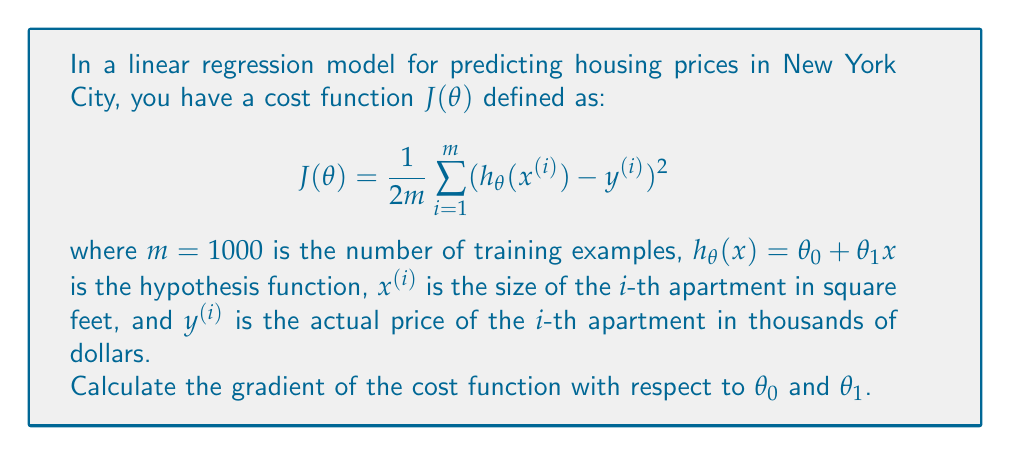Solve this math problem. To calculate the gradient of the cost function, we need to find the partial derivatives of $J(\theta)$ with respect to $\theta_0$ and $\theta_1$. Let's break this down step by step:

1) First, let's expand the hypothesis function in the cost function:
   $$J(\theta) = \frac{1}{2m} \sum_{i=1}^m ((\theta_0 + \theta_1x^{(i)}) - y^{(i)})^2$$

2) Now, let's calculate $\frac{\partial J}{\partial \theta_0}$:
   $$\begin{align}
   \frac{\partial J}{\partial \theta_0} &= \frac{\partial}{\partial \theta_0} \left[\frac{1}{2m} \sum_{i=1}^m ((\theta_0 + \theta_1x^{(i)}) - y^{(i)})^2\right] \\
   &= \frac{1}{2m} \sum_{i=1}^m 2((\theta_0 + \theta_1x^{(i)}) - y^{(i)}) \cdot \frac{\partial}{\partial \theta_0}(\theta_0 + \theta_1x^{(i)} - y^{(i)}) \\
   &= \frac{1}{m} \sum_{i=1}^m ((\theta_0 + \theta_1x^{(i)}) - y^{(i)}) \cdot 1 \\
   &= \frac{1}{m} \sum_{i=1}^m (h_\theta(x^{(i)}) - y^{(i)})
   \end{align}$$

3) Now, let's calculate $\frac{\partial J}{\partial \theta_1}$:
   $$\begin{align}
   \frac{\partial J}{\partial \theta_1} &= \frac{\partial}{\partial \theta_1} \left[\frac{1}{2m} \sum_{i=1}^m ((\theta_0 + \theta_1x^{(i)}) - y^{(i)})^2\right] \\
   &= \frac{1}{2m} \sum_{i=1}^m 2((\theta_0 + \theta_1x^{(i)}) - y^{(i)}) \cdot \frac{\partial}{\partial \theta_1}(\theta_0 + \theta_1x^{(i)} - y^{(i)}) \\
   &= \frac{1}{m} \sum_{i=1}^m ((\theta_0 + \theta_1x^{(i)}) - y^{(i)}) \cdot x^{(i)} \\
   &= \frac{1}{m} \sum_{i=1}^m (h_\theta(x^{(i)}) - y^{(i)}) \cdot x^{(i)}
   \end{align}$$

4) The gradient is a vector of these partial derivatives:
   $$\nabla J(\theta) = \left[\frac{\partial J}{\partial \theta_0}, \frac{\partial J}{\partial \theta_1}\right]$$
Answer: The gradient of the cost function $J(\theta)$ is:

$$\nabla J(\theta) = \left[\frac{1}{m} \sum_{i=1}^m (h_\theta(x^{(i)}) - y^{(i)}), \frac{1}{m} \sum_{i=1}^m (h_\theta(x^{(i)}) - y^{(i)}) \cdot x^{(i)}\right]$$

where $h_\theta(x^{(i)}) = \theta_0 + \theta_1x^{(i)}$. 